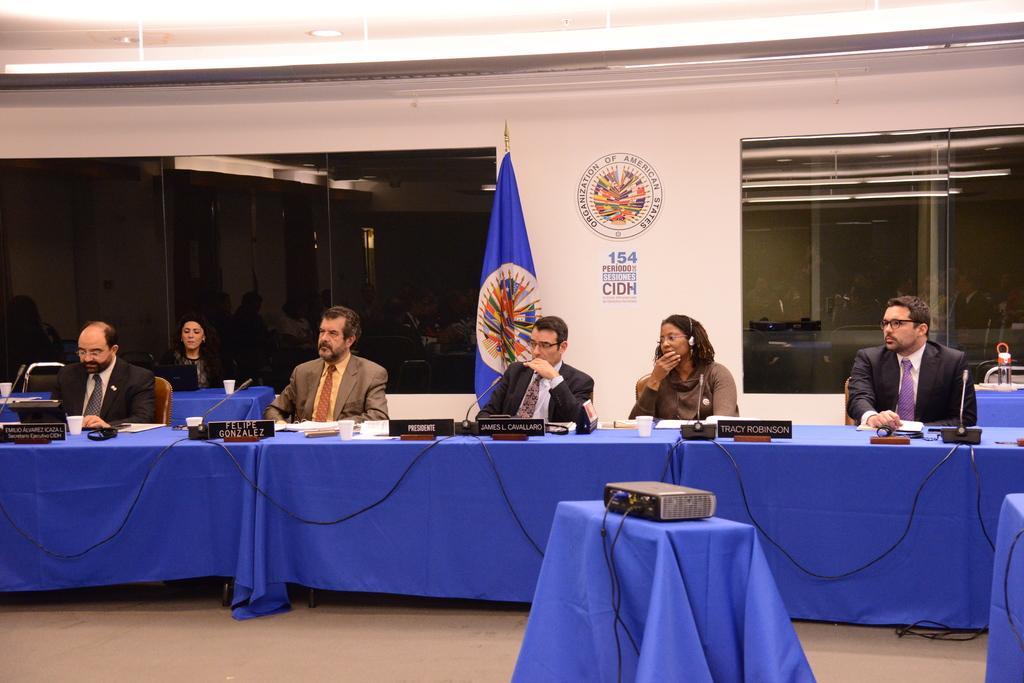Can you describe this image briefly? The image is taken in the room. There are tables and there are people sitting around the tables. In the center of the image there is a projector which is placed on the stand. There are glasses, papers, cups and mic´s placed on the table. In the background there is a flag and windows. 